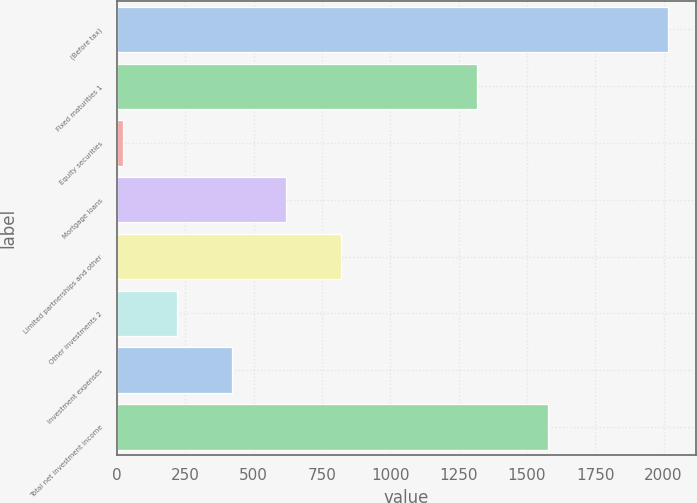Convert chart. <chart><loc_0><loc_0><loc_500><loc_500><bar_chart><fcel>(Before tax)<fcel>Fixed maturities 1<fcel>Equity securities<fcel>Mortgage loans<fcel>Limited partnerships and other<fcel>Other investments 2<fcel>Investment expenses<fcel>Total net investment income<nl><fcel>2016<fcel>1319<fcel>22<fcel>620.2<fcel>819.6<fcel>221.4<fcel>420.8<fcel>1577<nl></chart> 